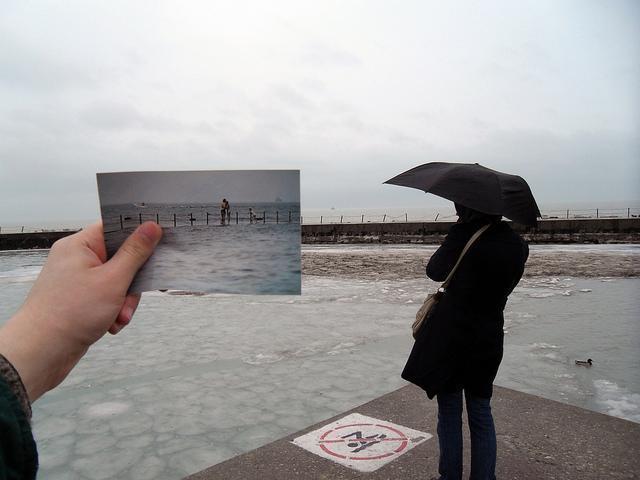How many people are there?
Give a very brief answer. 2. How many trains have a number on the front?
Give a very brief answer. 0. 